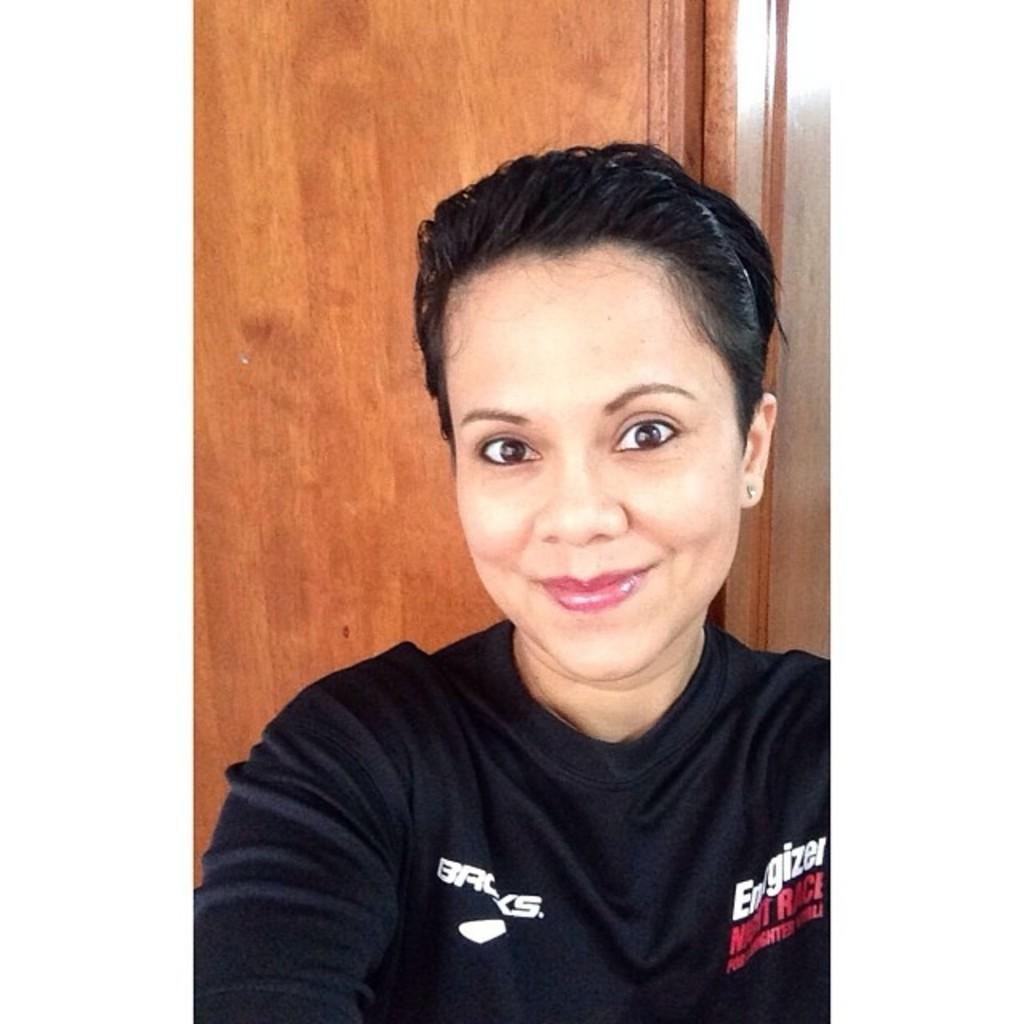<image>
Write a terse but informative summary of the picture. The shirt is being sponsored by the company Energizer 